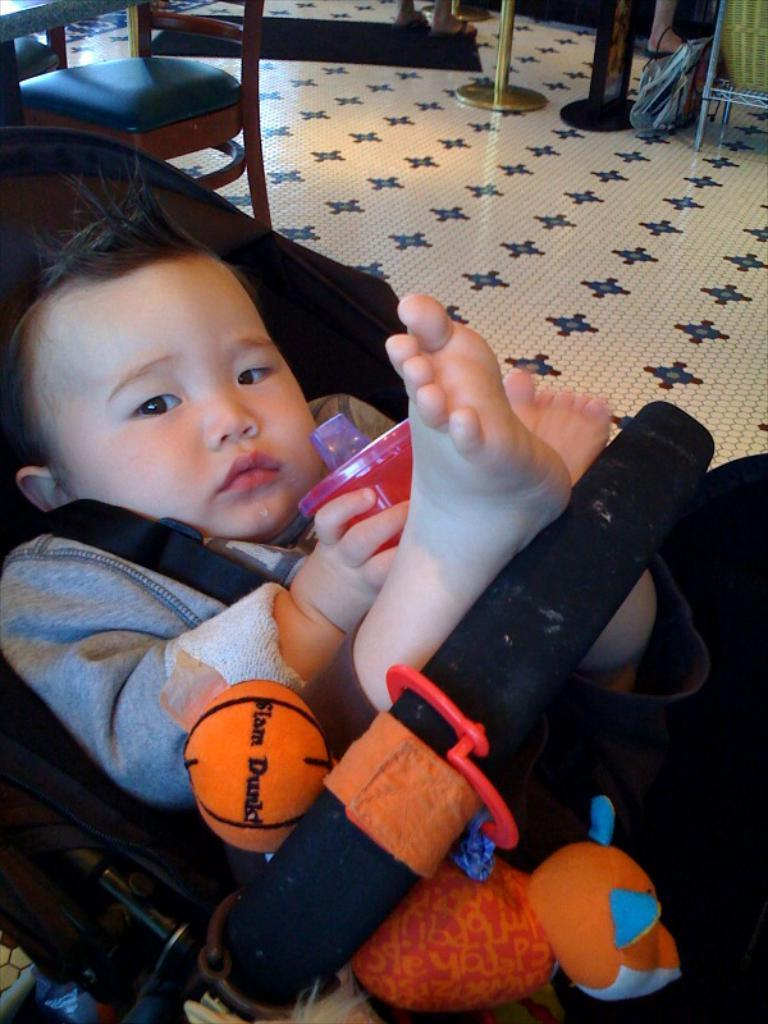What is the main subject of the image? There is a baby in the image. Where is the baby located? The baby is lying in a pram. What is the baby holding in their hands? The baby is holding a tumbler in their hands. What can be seen in the background of the image? There is a barrier pole, a floor, and a chair visible in the background of the image. What letter is the baby trying to write on the floor in the image? There is no letter visible on the floor in the image, and the baby is not shown writing anything. 